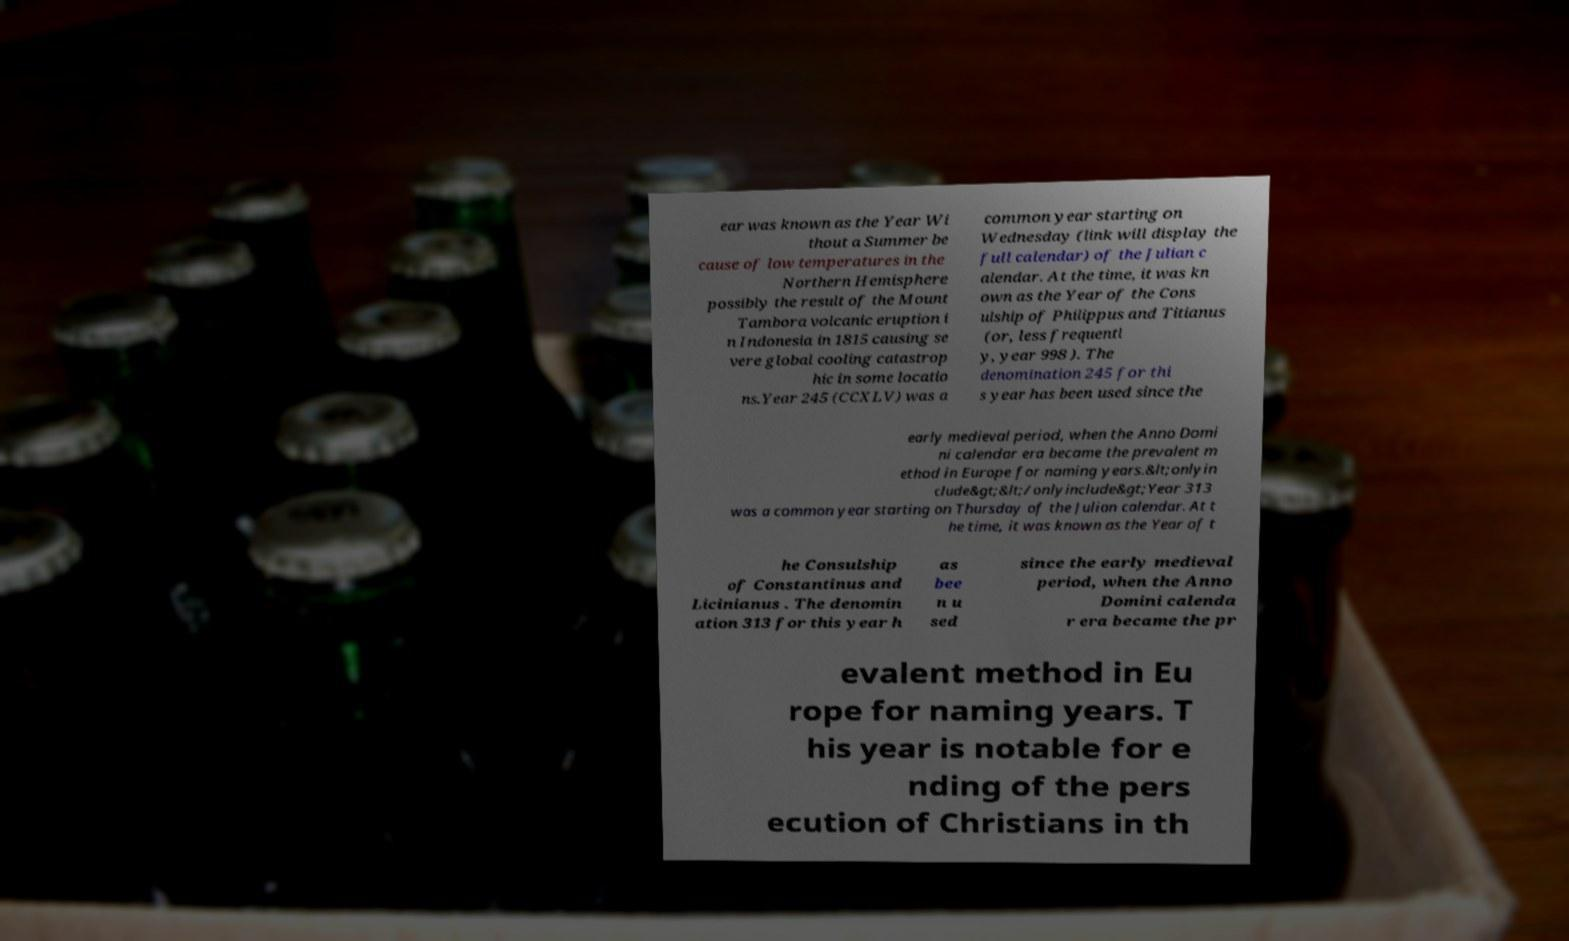Please read and relay the text visible in this image. What does it say? ear was known as the Year Wi thout a Summer be cause of low temperatures in the Northern Hemisphere possibly the result of the Mount Tambora volcanic eruption i n Indonesia in 1815 causing se vere global cooling catastrop hic in some locatio ns.Year 245 (CCXLV) was a common year starting on Wednesday (link will display the full calendar) of the Julian c alendar. At the time, it was kn own as the Year of the Cons ulship of Philippus and Titianus (or, less frequentl y, year 998 ). The denomination 245 for thi s year has been used since the early medieval period, when the Anno Domi ni calendar era became the prevalent m ethod in Europe for naming years.&lt;onlyin clude&gt;&lt;/onlyinclude&gt;Year 313 was a common year starting on Thursday of the Julian calendar. At t he time, it was known as the Year of t he Consulship of Constantinus and Licinianus . The denomin ation 313 for this year h as bee n u sed since the early medieval period, when the Anno Domini calenda r era became the pr evalent method in Eu rope for naming years. T his year is notable for e nding of the pers ecution of Christians in th 